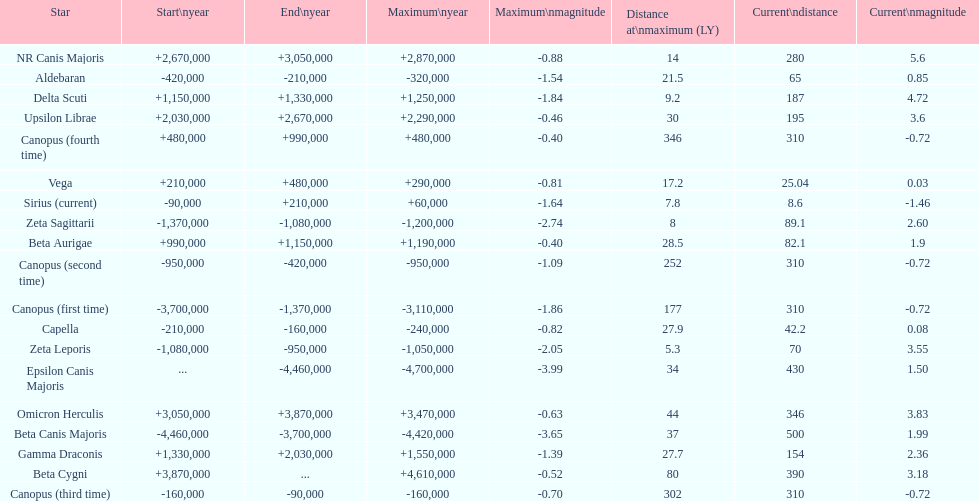How much farther (in ly) is epsilon canis majoris than zeta sagittarii? 26. 